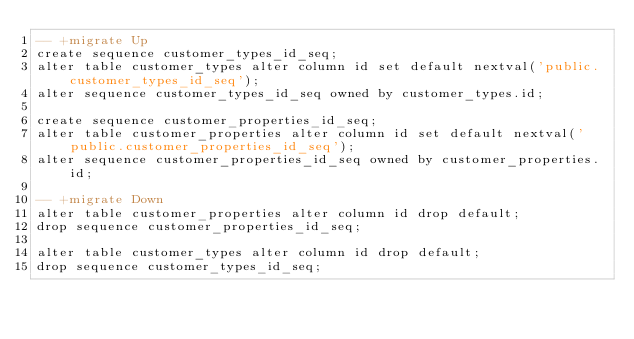<code> <loc_0><loc_0><loc_500><loc_500><_SQL_>-- +migrate Up
create sequence customer_types_id_seq;
alter table customer_types alter column id set default nextval('public.customer_types_id_seq');
alter sequence customer_types_id_seq owned by customer_types.id;

create sequence customer_properties_id_seq;
alter table customer_properties alter column id set default nextval('public.customer_properties_id_seq');
alter sequence customer_properties_id_seq owned by customer_properties.id;

-- +migrate Down
alter table customer_properties alter column id drop default;
drop sequence customer_properties_id_seq;

alter table customer_types alter column id drop default;
drop sequence customer_types_id_seq;
</code> 